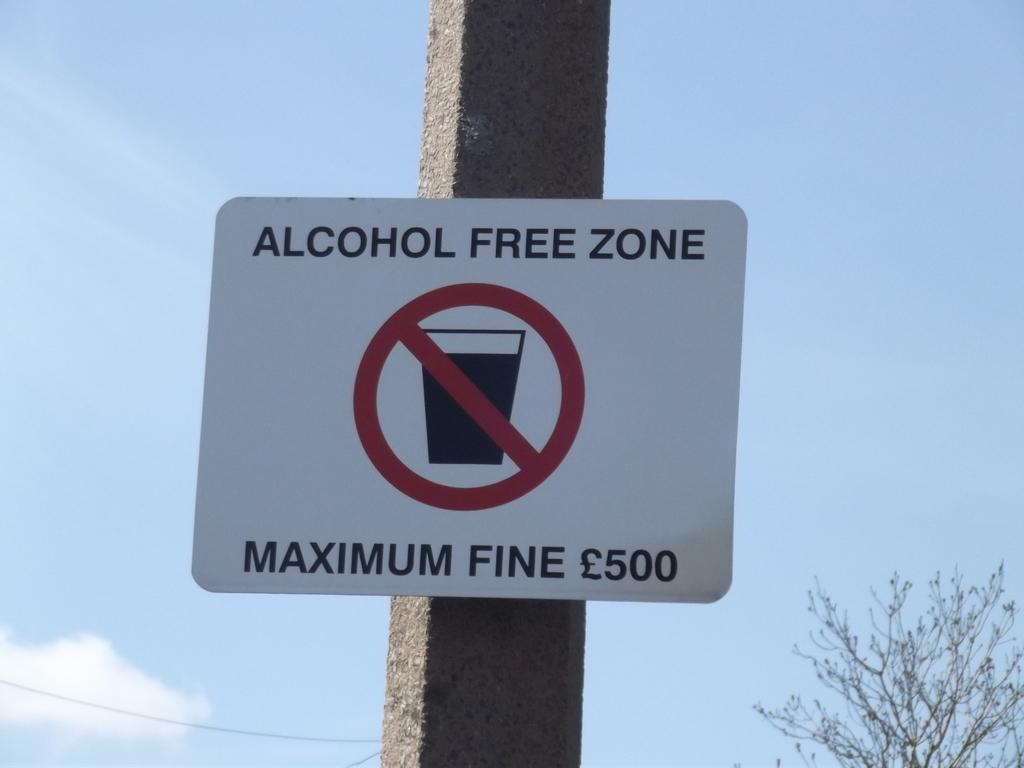Provide a one-sentence caption for the provided image. A sign designates an alcohol free zone and that there is a fine. 